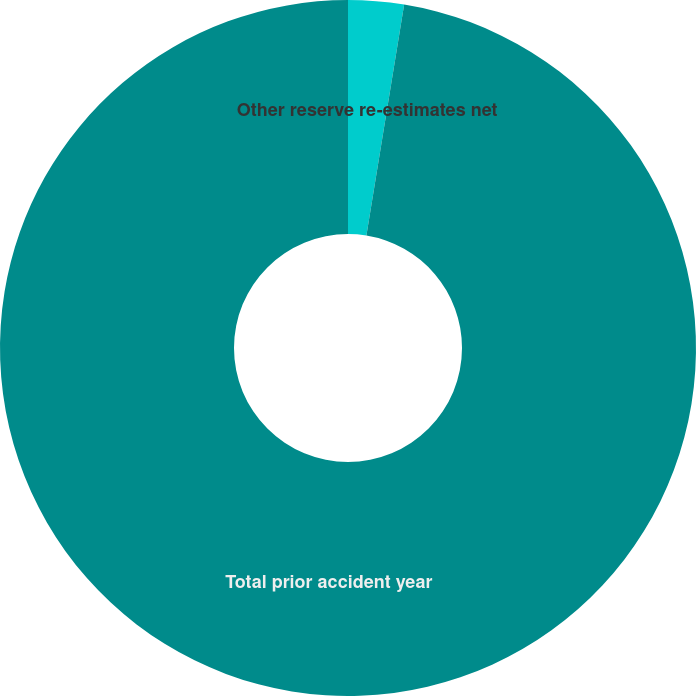<chart> <loc_0><loc_0><loc_500><loc_500><pie_chart><fcel>Other reserve re-estimates net<fcel>Total prior accident year<nl><fcel>2.58%<fcel>97.42%<nl></chart> 